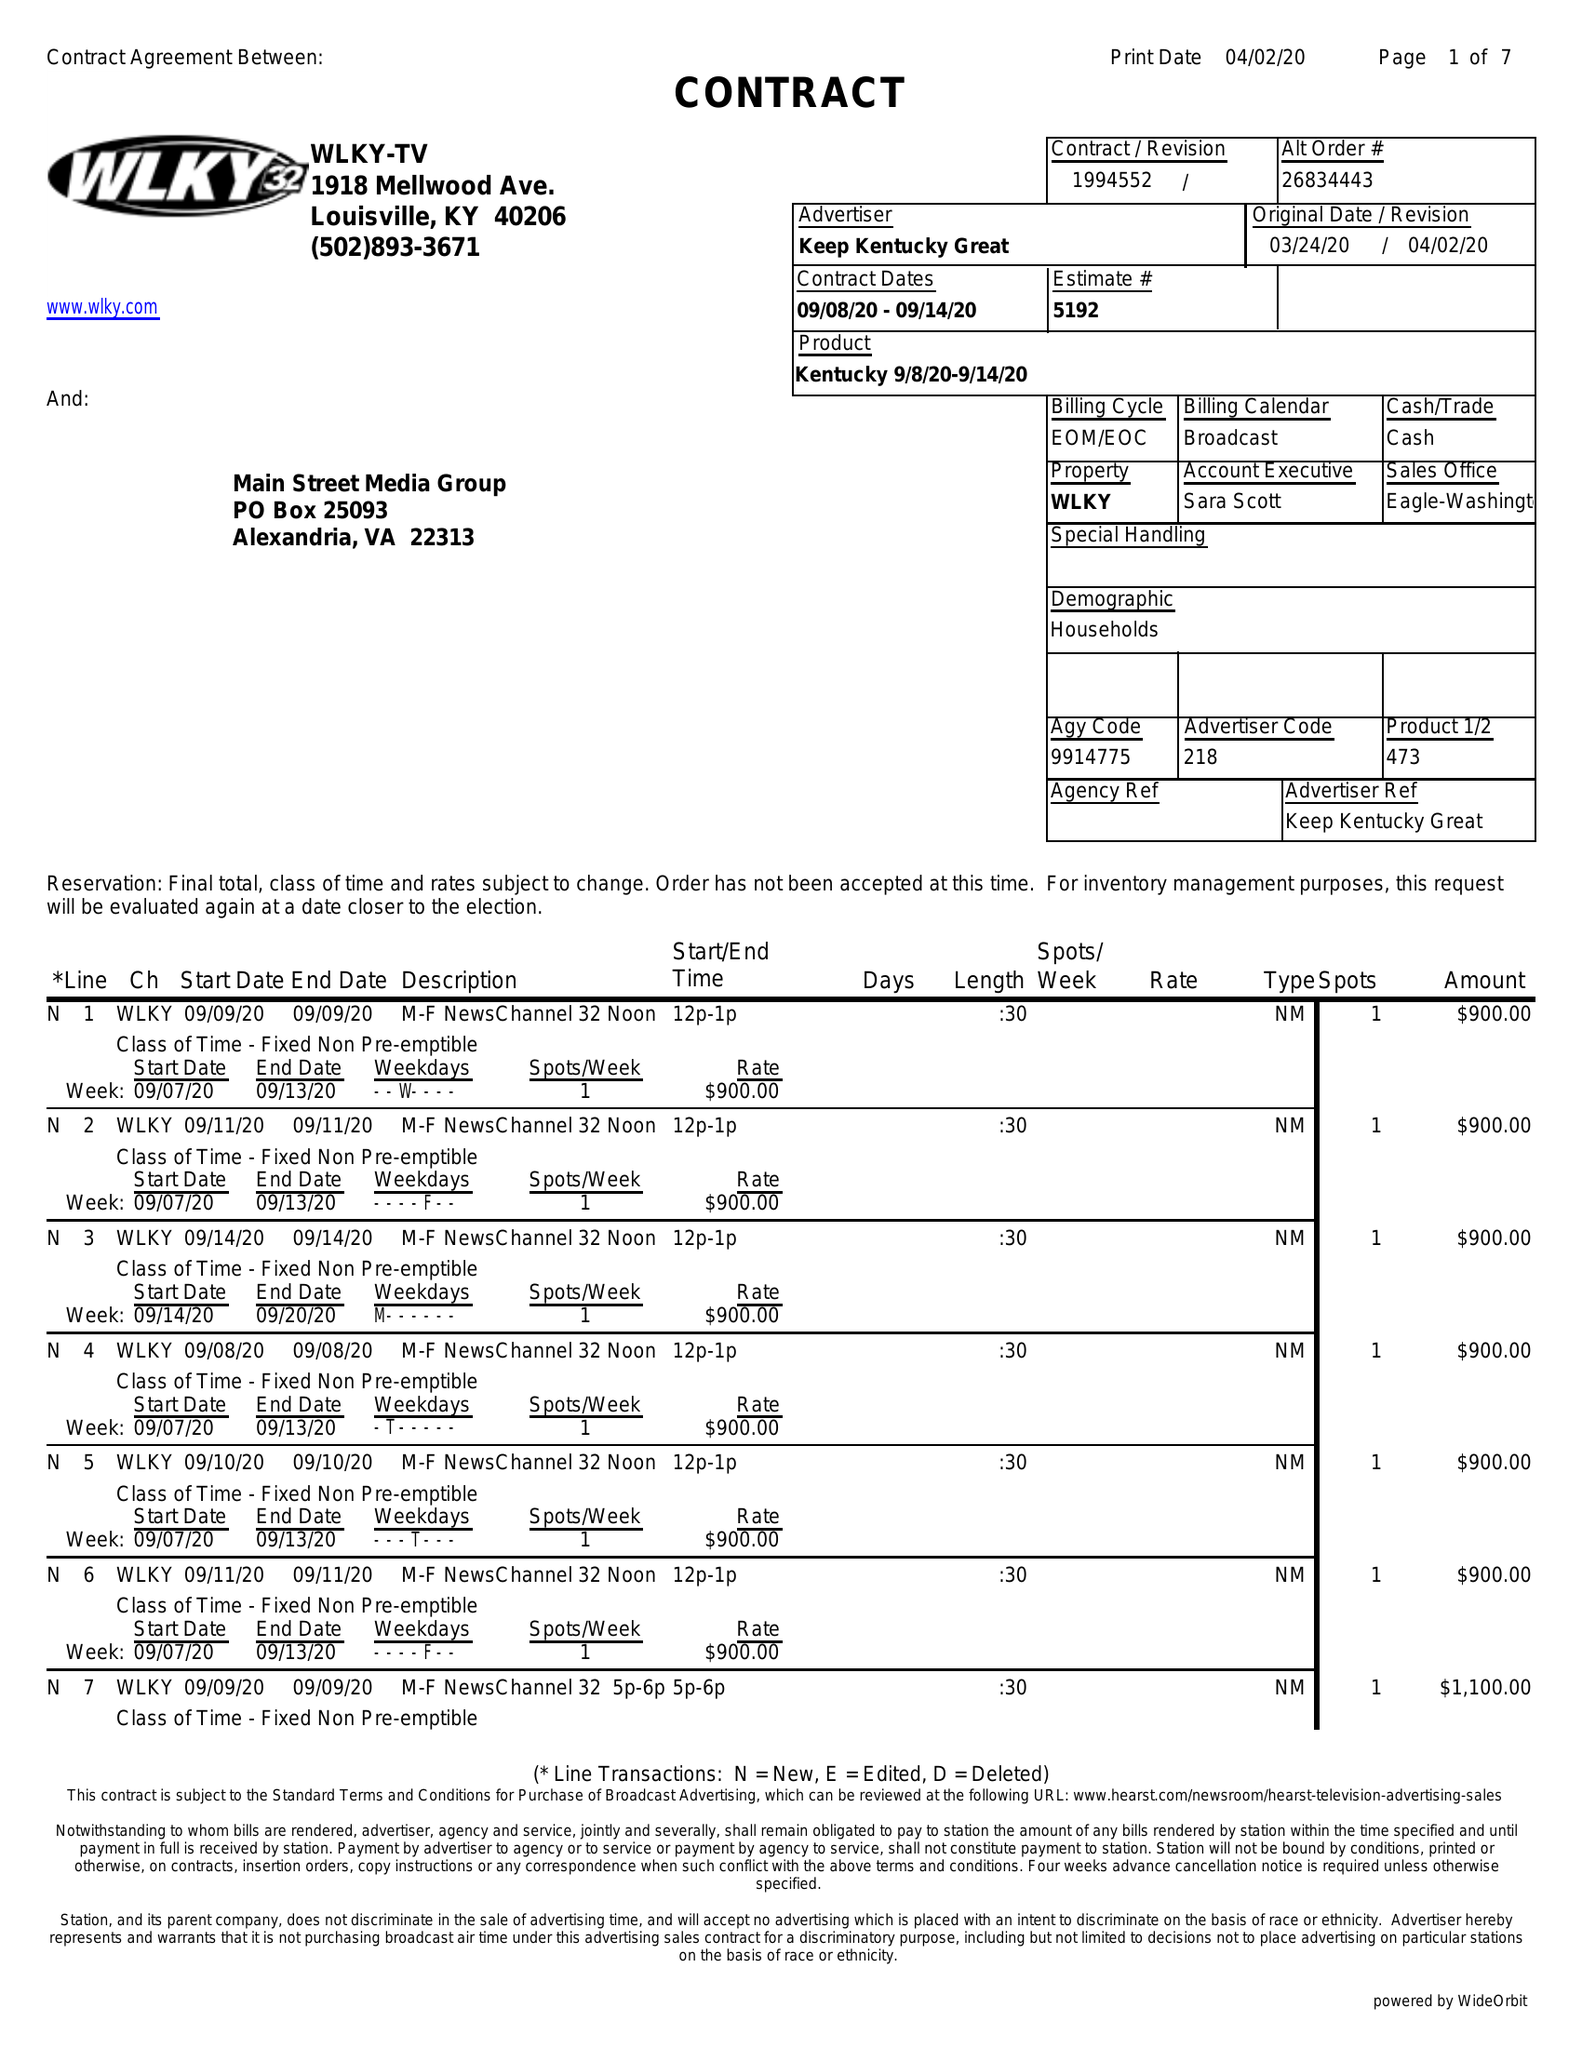What is the value for the gross_amount?
Answer the question using a single word or phrase. 81150.00 